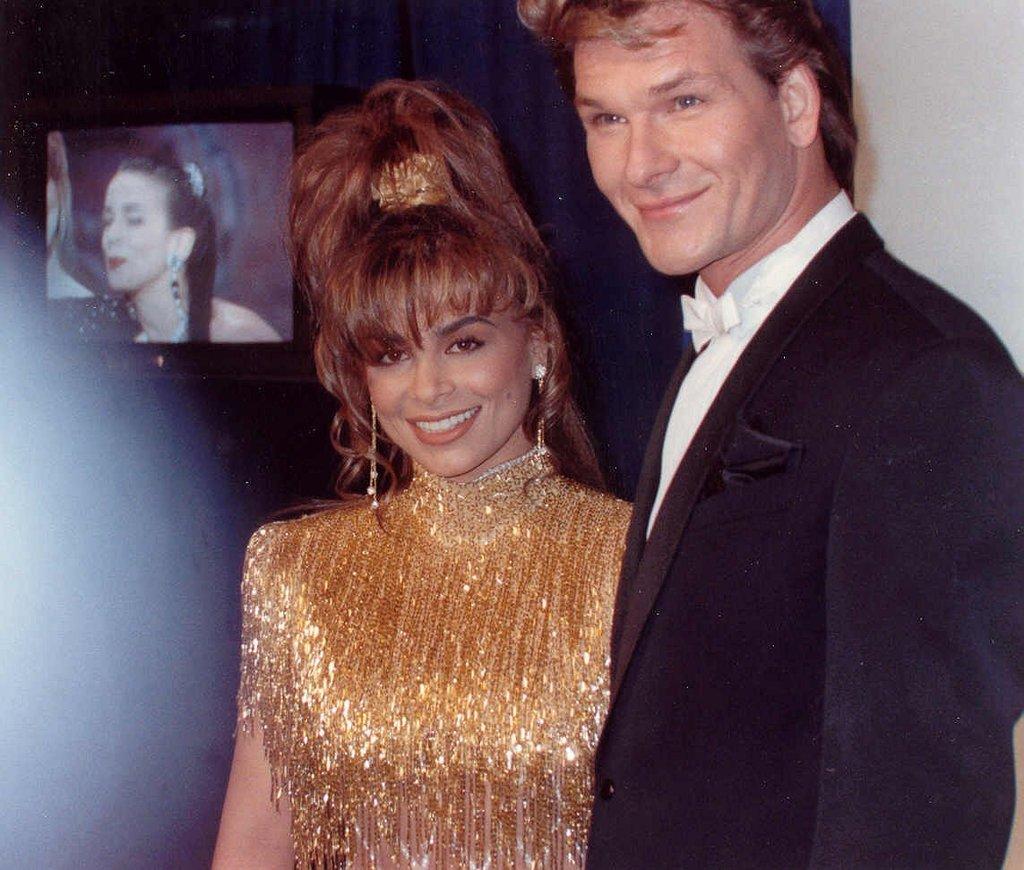Please provide a concise description of this image. In this image there is a man and a woman with a smile on their face, behind them there is a television. 